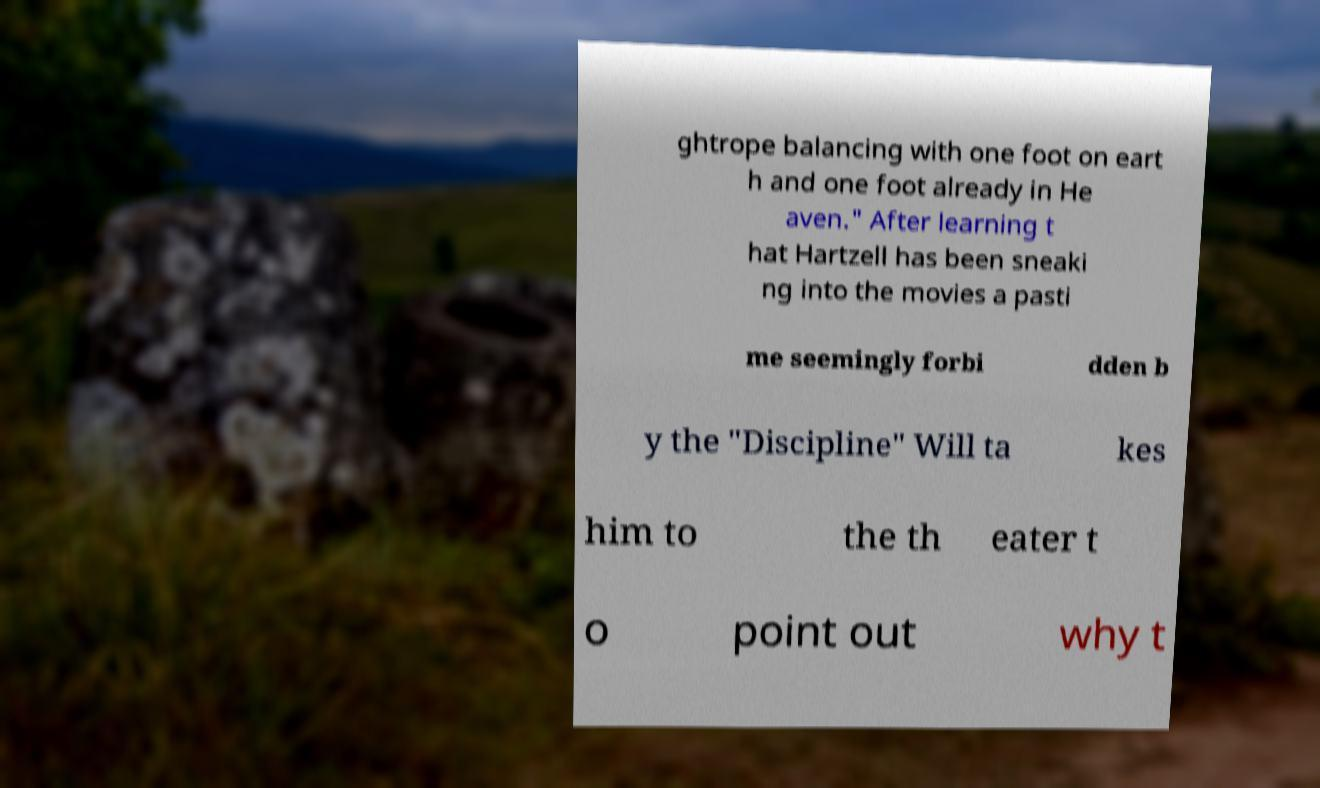Can you accurately transcribe the text from the provided image for me? ghtrope balancing with one foot on eart h and one foot already in He aven." After learning t hat Hartzell has been sneaki ng into the movies a pasti me seemingly forbi dden b y the "Discipline" Will ta kes him to the th eater t o point out why t 